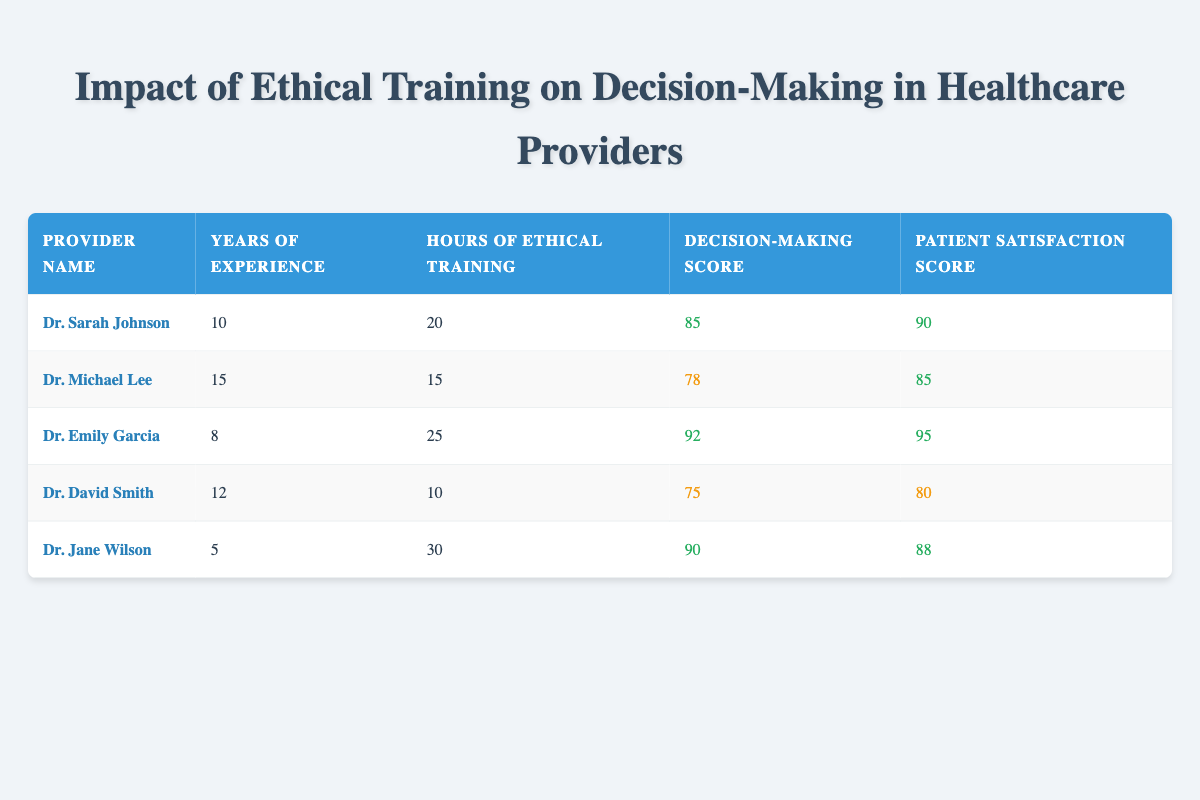What is the decision-making score of Dr. Emily Garcia? The table lists Dr. Emily Garcia's decision-making score in the row dedicated to her information. It shows a decision-making score of 92.
Answer: 92 Which provider has the highest patient satisfaction score? By looking at the patient satisfaction scores, we can see Dr. Emily Garcia has the highest score of 95, compared to other providers.
Answer: Dr. Emily Garcia What is the average years of experience among the healthcare providers? To calculate the average years of experience, we sum the years of experience: (10 + 15 + 8 + 12 + 5) = 50, then divide by the number of providers (5), which gives us 50/5 = 10.
Answer: 10 Is it true that Dr. Jane Wilson has more hours of ethical training than Dr. David Smith? A comparison of hours shows that Dr. Jane Wilson has 30 hours, whereas Dr. David Smith has 10 hours. Therefore, Dr. Jane Wilson has more hours of ethical training.
Answer: Yes What is the total decision-making score for all providers combined? We calculate the total score by summing each provider's decision-making score: (85 + 78 + 92 + 75 + 90) = 420.
Answer: 420 Which provider has the least years of experience and what is their decision-making score? Dr. Jane Wilson has the least years of experience (5 years) among the providers, and her decision-making score is 90.
Answer: Dr. Jane Wilson, 90 What is the difference in patient satisfaction scores between the highest and lowest scores? The highest patient satisfaction score is 95 (Dr. Emily Garcia) and the lowest is 80 (Dr. David Smith). The difference is 95 - 80 = 15.
Answer: 15 How many hours of ethical training does Dr. Sarah Johnson have compared to Dr. Michael Lee? Dr. Sarah Johnson has 20 hours of ethical training, while Dr. Michael Lee has 15 hours. Thus, Dr. Sarah Johnson has 5 more hours of ethical training.
Answer: 5 Which provider has the longest experience among the group? Dr. Michael Lee has the longest experience with 15 years, as shown in his row of data compared to the others.
Answer: Dr. Michael Lee 